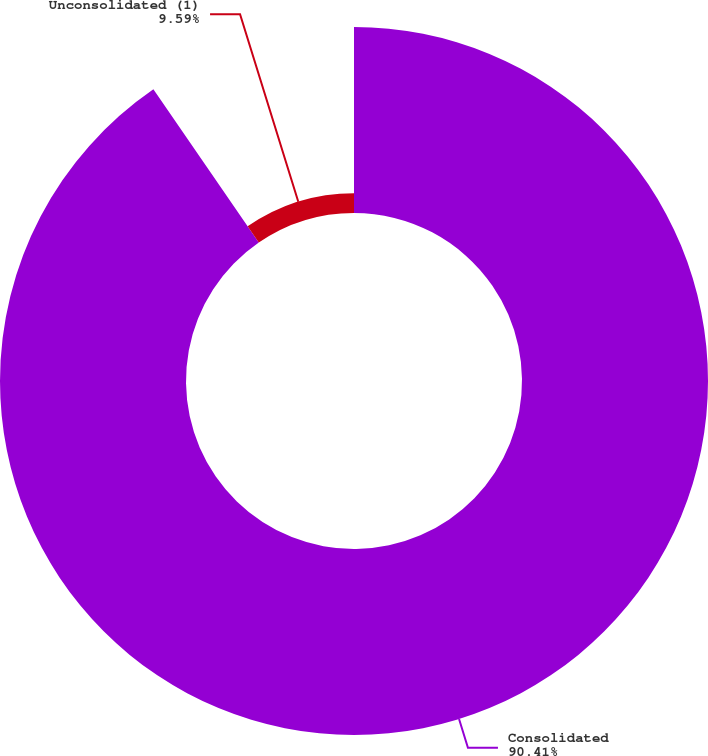Convert chart to OTSL. <chart><loc_0><loc_0><loc_500><loc_500><pie_chart><fcel>Consolidated<fcel>Unconsolidated (1)<nl><fcel>90.41%<fcel>9.59%<nl></chart> 